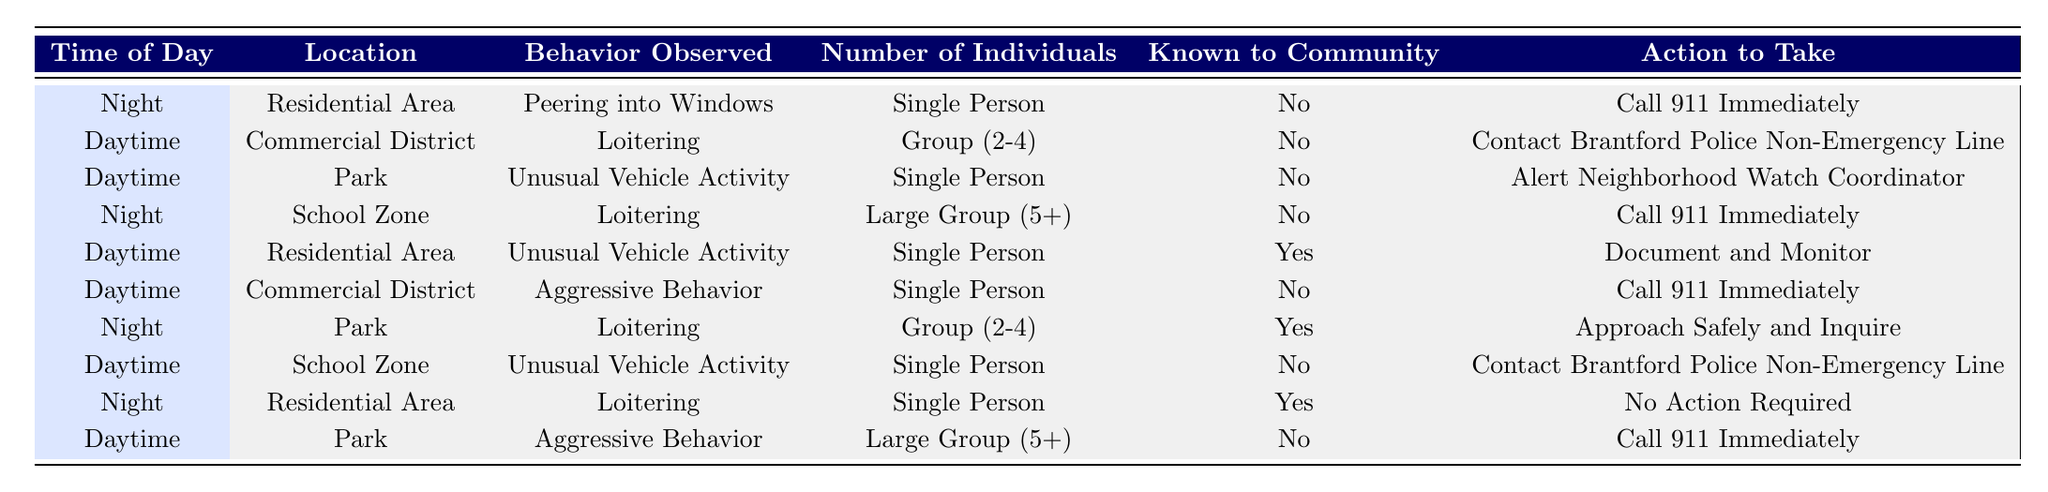What action is recommended when observing loitering by a single person in a residential area at night who is not known to the community? According to the rules in the table, if a person observes loitering by a single person in a residential area at night and the individual is not known to the community, the recommended action is to "Call 911 Immediately."
Answer: Call 911 Immediately What should be done if unusual vehicle activity is observed during the daytime in a park by a single person who is not known to the community? The table indicates that if unusual vehicle activity is observed during the daytime in a park by a single individual who is not known to the community, the action to take is to "Alert Neighborhood Watch Coordinator."
Answer: Alert Neighborhood Watch Coordinator Are there any instances in the table where no action is required? Yes, one instance shows that if loitering is observed by a single person in a residential area at night and the individual is known to the community, "No Action Required." Therefore, this confirms that action is not always needed in certain observations.
Answer: Yes How many situations result in calling 911 immediately? By reviewing the actions in the table, there are 4 instances where the action specified is to "Call 911 Immediately." These are noted in the rows for specific combinations of time, location, behavior, and community knowledge.
Answer: 4 If a large group (5+) is seen exhibiting aggressive behavior in a park during the daytime, what action should be taken? According to the table, if aggressive behavior is being displayed by a large group in a park during the daytime, the action is to "Call 911 Immediately." This is directly listed as a rule in the table.
Answer: Call 911 Immediately What are the possible actions for observing loitering by a group of 2-4 individuals known to the community at night? The table shows that if loitering occurs with a group of 2-4 individuals in the park at night, the action to take is "Approach Safely and Inquire." However, in the residential area, if similar conditions exist, there is no action required. Thus, the only action possible under these conditions is to approach and inquire.
Answer: Approach Safely and Inquire What time of day and location combination requires contacting the Brantford Police Non-Emergency Line? Based on the data in the table, the combinations that warrant contacting the Brantford Police Non-Emergency Line are: daytime in a commercial district with loitering by a group of 2-4 (who are not known to the community) and the school zone with unusual vehicle activity by a single person (who is not known to the community).
Answer: Daytime, Commercial District; Daytime, School Zone If someone observes aggressive behavior in a commercial district during the daytime by a single person who is not known, what should they do? The table clearly states that in such a case, the action to take is to "Call 911 Immediately." This is one of the critical responses outlined for aggressive behavior not known to the community.
Answer: Call 911 Immediately 